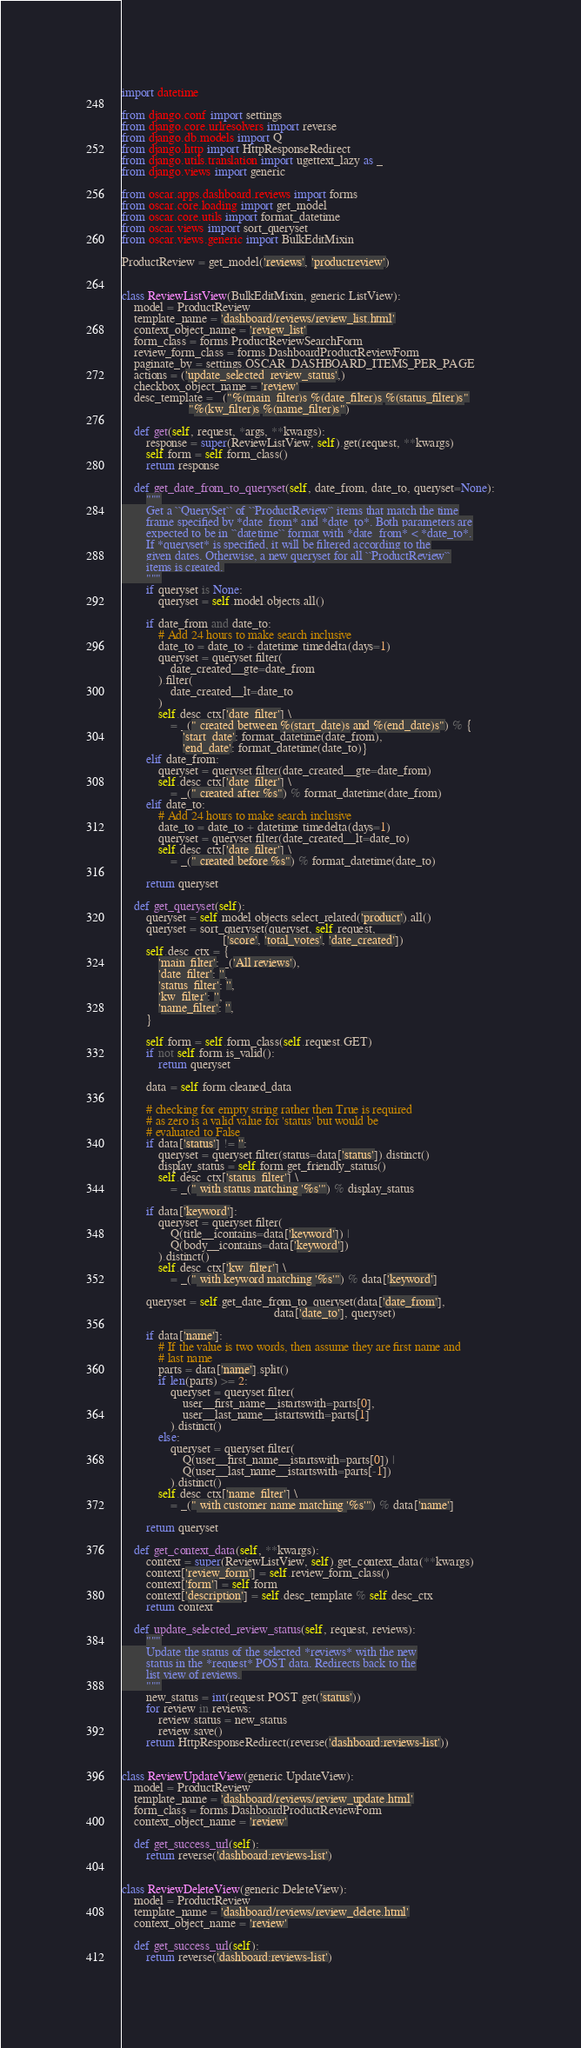<code> <loc_0><loc_0><loc_500><loc_500><_Python_>import datetime

from django.conf import settings
from django.core.urlresolvers import reverse
from django.db.models import Q
from django.http import HttpResponseRedirect
from django.utils.translation import ugettext_lazy as _
from django.views import generic

from oscar.apps.dashboard.reviews import forms
from oscar.core.loading import get_model
from oscar.core.utils import format_datetime
from oscar.views import sort_queryset
from oscar.views.generic import BulkEditMixin

ProductReview = get_model('reviews', 'productreview')


class ReviewListView(BulkEditMixin, generic.ListView):
    model = ProductReview
    template_name = 'dashboard/reviews/review_list.html'
    context_object_name = 'review_list'
    form_class = forms.ProductReviewSearchForm
    review_form_class = forms.DashboardProductReviewForm
    paginate_by = settings.OSCAR_DASHBOARD_ITEMS_PER_PAGE
    actions = ('update_selected_review_status',)
    checkbox_object_name = 'review'
    desc_template = _("%(main_filter)s %(date_filter)s %(status_filter)s"
                      "%(kw_filter)s %(name_filter)s")

    def get(self, request, *args, **kwargs):
        response = super(ReviewListView, self).get(request, **kwargs)
        self.form = self.form_class()
        return response

    def get_date_from_to_queryset(self, date_from, date_to, queryset=None):
        """
        Get a ``QuerySet`` of ``ProductReview`` items that match the time
        frame specified by *date_from* and *date_to*. Both parameters are
        expected to be in ``datetime`` format with *date_from* < *date_to*.
        If *queryset* is specified, it will be filtered according to the
        given dates. Otherwise, a new queryset for all ``ProductReview``
        items is created.
        """
        if queryset is None:
            queryset = self.model.objects.all()

        if date_from and date_to:
            # Add 24 hours to make search inclusive
            date_to = date_to + datetime.timedelta(days=1)
            queryset = queryset.filter(
                date_created__gte=date_from
            ).filter(
                date_created__lt=date_to
            )
            self.desc_ctx['date_filter'] \
                = _(" created between %(start_date)s and %(end_date)s") % {
                    'start_date': format_datetime(date_from),
                    'end_date': format_datetime(date_to)}
        elif date_from:
            queryset = queryset.filter(date_created__gte=date_from)
            self.desc_ctx['date_filter'] \
                = _(" created after %s") % format_datetime(date_from)
        elif date_to:
            # Add 24 hours to make search inclusive
            date_to = date_to + datetime.timedelta(days=1)
            queryset = queryset.filter(date_created__lt=date_to)
            self.desc_ctx['date_filter'] \
                = _(" created before %s") % format_datetime(date_to)

        return queryset

    def get_queryset(self):
        queryset = self.model.objects.select_related('product').all()
        queryset = sort_queryset(queryset, self.request,
                                 ['score', 'total_votes', 'date_created'])
        self.desc_ctx = {
            'main_filter': _('All reviews'),
            'date_filter': '',
            'status_filter': '',
            'kw_filter': '',
            'name_filter': '',
        }

        self.form = self.form_class(self.request.GET)
        if not self.form.is_valid():
            return queryset

        data = self.form.cleaned_data

        # checking for empty string rather then True is required
        # as zero is a valid value for 'status' but would be
        # evaluated to False
        if data['status'] != '':
            queryset = queryset.filter(status=data['status']).distinct()
            display_status = self.form.get_friendly_status()
            self.desc_ctx['status_filter'] \
                = _(" with status matching '%s'") % display_status

        if data['keyword']:
            queryset = queryset.filter(
                Q(title__icontains=data['keyword']) |
                Q(body__icontains=data['keyword'])
            ).distinct()
            self.desc_ctx['kw_filter'] \
                = _(" with keyword matching '%s'") % data['keyword']

        queryset = self.get_date_from_to_queryset(data['date_from'],
                                                  data['date_to'], queryset)

        if data['name']:
            # If the value is two words, then assume they are first name and
            # last name
            parts = data['name'].split()
            if len(parts) >= 2:
                queryset = queryset.filter(
                    user__first_name__istartswith=parts[0],
                    user__last_name__istartswith=parts[1]
                ).distinct()
            else:
                queryset = queryset.filter(
                    Q(user__first_name__istartswith=parts[0]) |
                    Q(user__last_name__istartswith=parts[-1])
                ).distinct()
            self.desc_ctx['name_filter'] \
                = _(" with customer name matching '%s'") % data['name']

        return queryset

    def get_context_data(self, **kwargs):
        context = super(ReviewListView, self).get_context_data(**kwargs)
        context['review_form'] = self.review_form_class()
        context['form'] = self.form
        context['description'] = self.desc_template % self.desc_ctx
        return context

    def update_selected_review_status(self, request, reviews):
        """
        Update the status of the selected *reviews* with the new
        status in the *request* POST data. Redirects back to the
        list view of reviews.
        """
        new_status = int(request.POST.get('status'))
        for review in reviews:
            review.status = new_status
            review.save()
        return HttpResponseRedirect(reverse('dashboard:reviews-list'))


class ReviewUpdateView(generic.UpdateView):
    model = ProductReview
    template_name = 'dashboard/reviews/review_update.html'
    form_class = forms.DashboardProductReviewForm
    context_object_name = 'review'

    def get_success_url(self):
        return reverse('dashboard:reviews-list')


class ReviewDeleteView(generic.DeleteView):
    model = ProductReview
    template_name = 'dashboard/reviews/review_delete.html'
    context_object_name = 'review'

    def get_success_url(self):
        return reverse('dashboard:reviews-list')
</code> 